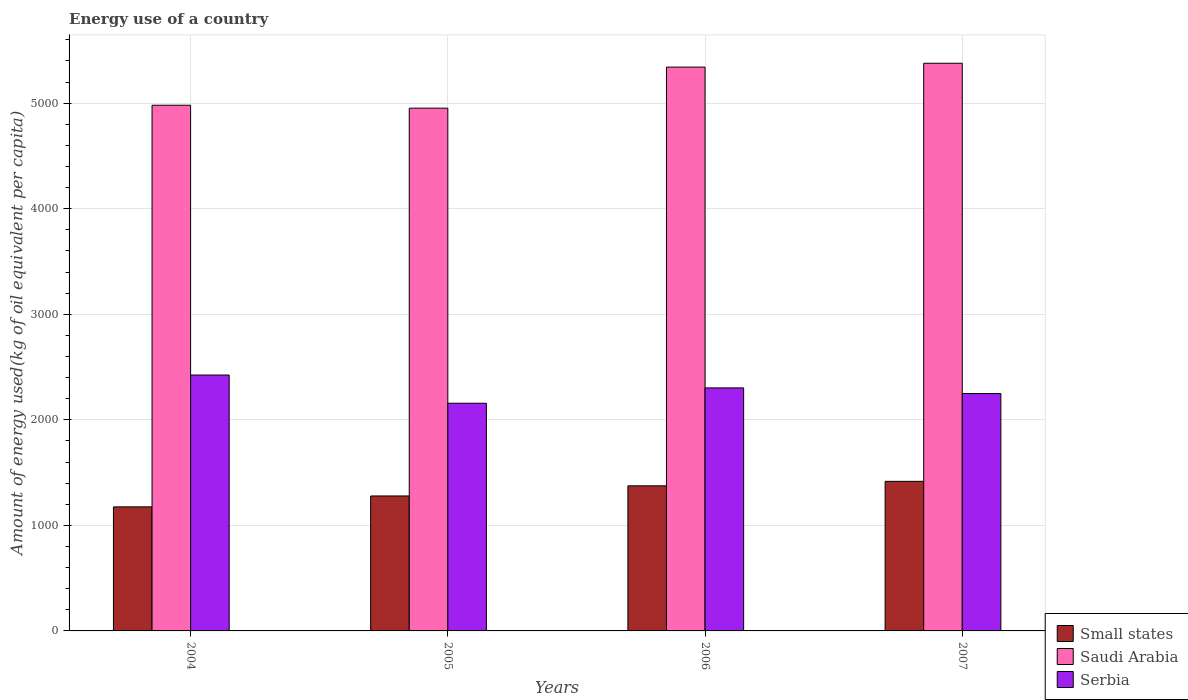How many different coloured bars are there?
Ensure brevity in your answer.  3. Are the number of bars per tick equal to the number of legend labels?
Keep it short and to the point. Yes. Are the number of bars on each tick of the X-axis equal?
Ensure brevity in your answer.  Yes. What is the label of the 4th group of bars from the left?
Keep it short and to the point. 2007. In how many cases, is the number of bars for a given year not equal to the number of legend labels?
Your answer should be very brief. 0. What is the amount of energy used in in Small states in 2007?
Ensure brevity in your answer.  1417.19. Across all years, what is the maximum amount of energy used in in Small states?
Your response must be concise. 1417.19. Across all years, what is the minimum amount of energy used in in Serbia?
Offer a very short reply. 2157.16. In which year was the amount of energy used in in Serbia maximum?
Give a very brief answer. 2004. What is the total amount of energy used in in Small states in the graph?
Your response must be concise. 5245.68. What is the difference between the amount of energy used in in Serbia in 2005 and that in 2006?
Your answer should be compact. -145.23. What is the difference between the amount of energy used in in Small states in 2007 and the amount of energy used in in Serbia in 2005?
Your answer should be very brief. -739.97. What is the average amount of energy used in in Saudi Arabia per year?
Provide a short and direct response. 5163.19. In the year 2006, what is the difference between the amount of energy used in in Saudi Arabia and amount of energy used in in Serbia?
Provide a succinct answer. 3039.44. In how many years, is the amount of energy used in in Saudi Arabia greater than 200 kg?
Your answer should be compact. 4. What is the ratio of the amount of energy used in in Serbia in 2004 to that in 2006?
Keep it short and to the point. 1.05. Is the difference between the amount of energy used in in Saudi Arabia in 2004 and 2005 greater than the difference between the amount of energy used in in Serbia in 2004 and 2005?
Your answer should be compact. No. What is the difference between the highest and the second highest amount of energy used in in Small states?
Offer a terse response. 42.63. What is the difference between the highest and the lowest amount of energy used in in Small states?
Your answer should be compact. 241.94. In how many years, is the amount of energy used in in Serbia greater than the average amount of energy used in in Serbia taken over all years?
Offer a very short reply. 2. What does the 2nd bar from the left in 2005 represents?
Provide a succinct answer. Saudi Arabia. What does the 1st bar from the right in 2007 represents?
Make the answer very short. Serbia. How many bars are there?
Your answer should be very brief. 12. Are all the bars in the graph horizontal?
Keep it short and to the point. No. Does the graph contain grids?
Offer a terse response. Yes. How many legend labels are there?
Provide a succinct answer. 3. What is the title of the graph?
Provide a short and direct response. Energy use of a country. Does "Low & middle income" appear as one of the legend labels in the graph?
Provide a succinct answer. No. What is the label or title of the X-axis?
Your answer should be very brief. Years. What is the label or title of the Y-axis?
Your answer should be very brief. Amount of energy used(kg of oil equivalent per capita). What is the Amount of energy used(kg of oil equivalent per capita) of Small states in 2004?
Offer a terse response. 1175.26. What is the Amount of energy used(kg of oil equivalent per capita) in Saudi Arabia in 2004?
Make the answer very short. 4980.31. What is the Amount of energy used(kg of oil equivalent per capita) in Serbia in 2004?
Provide a short and direct response. 2424.4. What is the Amount of energy used(kg of oil equivalent per capita) in Small states in 2005?
Make the answer very short. 1278.65. What is the Amount of energy used(kg of oil equivalent per capita) of Saudi Arabia in 2005?
Provide a succinct answer. 4952.56. What is the Amount of energy used(kg of oil equivalent per capita) in Serbia in 2005?
Your answer should be compact. 2157.16. What is the Amount of energy used(kg of oil equivalent per capita) of Small states in 2006?
Your answer should be very brief. 1374.57. What is the Amount of energy used(kg of oil equivalent per capita) of Saudi Arabia in 2006?
Keep it short and to the point. 5341.83. What is the Amount of energy used(kg of oil equivalent per capita) in Serbia in 2006?
Offer a very short reply. 2302.39. What is the Amount of energy used(kg of oil equivalent per capita) in Small states in 2007?
Ensure brevity in your answer.  1417.19. What is the Amount of energy used(kg of oil equivalent per capita) in Saudi Arabia in 2007?
Your response must be concise. 5378.06. What is the Amount of energy used(kg of oil equivalent per capita) in Serbia in 2007?
Offer a very short reply. 2249.08. Across all years, what is the maximum Amount of energy used(kg of oil equivalent per capita) in Small states?
Offer a terse response. 1417.19. Across all years, what is the maximum Amount of energy used(kg of oil equivalent per capita) of Saudi Arabia?
Your answer should be very brief. 5378.06. Across all years, what is the maximum Amount of energy used(kg of oil equivalent per capita) of Serbia?
Your answer should be compact. 2424.4. Across all years, what is the minimum Amount of energy used(kg of oil equivalent per capita) in Small states?
Provide a short and direct response. 1175.26. Across all years, what is the minimum Amount of energy used(kg of oil equivalent per capita) in Saudi Arabia?
Offer a very short reply. 4952.56. Across all years, what is the minimum Amount of energy used(kg of oil equivalent per capita) of Serbia?
Offer a very short reply. 2157.16. What is the total Amount of energy used(kg of oil equivalent per capita) in Small states in the graph?
Provide a short and direct response. 5245.68. What is the total Amount of energy used(kg of oil equivalent per capita) in Saudi Arabia in the graph?
Offer a very short reply. 2.07e+04. What is the total Amount of energy used(kg of oil equivalent per capita) in Serbia in the graph?
Ensure brevity in your answer.  9133.04. What is the difference between the Amount of energy used(kg of oil equivalent per capita) of Small states in 2004 and that in 2005?
Give a very brief answer. -103.39. What is the difference between the Amount of energy used(kg of oil equivalent per capita) of Saudi Arabia in 2004 and that in 2005?
Offer a very short reply. 27.75. What is the difference between the Amount of energy used(kg of oil equivalent per capita) in Serbia in 2004 and that in 2005?
Your answer should be compact. 267.24. What is the difference between the Amount of energy used(kg of oil equivalent per capita) of Small states in 2004 and that in 2006?
Give a very brief answer. -199.31. What is the difference between the Amount of energy used(kg of oil equivalent per capita) in Saudi Arabia in 2004 and that in 2006?
Your answer should be very brief. -361.52. What is the difference between the Amount of energy used(kg of oil equivalent per capita) in Serbia in 2004 and that in 2006?
Your response must be concise. 122.01. What is the difference between the Amount of energy used(kg of oil equivalent per capita) of Small states in 2004 and that in 2007?
Give a very brief answer. -241.94. What is the difference between the Amount of energy used(kg of oil equivalent per capita) of Saudi Arabia in 2004 and that in 2007?
Provide a succinct answer. -397.74. What is the difference between the Amount of energy used(kg of oil equivalent per capita) of Serbia in 2004 and that in 2007?
Offer a very short reply. 175.33. What is the difference between the Amount of energy used(kg of oil equivalent per capita) of Small states in 2005 and that in 2006?
Offer a terse response. -95.91. What is the difference between the Amount of energy used(kg of oil equivalent per capita) of Saudi Arabia in 2005 and that in 2006?
Your answer should be very brief. -389.27. What is the difference between the Amount of energy used(kg of oil equivalent per capita) in Serbia in 2005 and that in 2006?
Your answer should be compact. -145.23. What is the difference between the Amount of energy used(kg of oil equivalent per capita) in Small states in 2005 and that in 2007?
Give a very brief answer. -138.54. What is the difference between the Amount of energy used(kg of oil equivalent per capita) of Saudi Arabia in 2005 and that in 2007?
Make the answer very short. -425.5. What is the difference between the Amount of energy used(kg of oil equivalent per capita) of Serbia in 2005 and that in 2007?
Offer a terse response. -91.92. What is the difference between the Amount of energy used(kg of oil equivalent per capita) in Small states in 2006 and that in 2007?
Provide a short and direct response. -42.63. What is the difference between the Amount of energy used(kg of oil equivalent per capita) of Saudi Arabia in 2006 and that in 2007?
Make the answer very short. -36.23. What is the difference between the Amount of energy used(kg of oil equivalent per capita) of Serbia in 2006 and that in 2007?
Provide a succinct answer. 53.31. What is the difference between the Amount of energy used(kg of oil equivalent per capita) in Small states in 2004 and the Amount of energy used(kg of oil equivalent per capita) in Saudi Arabia in 2005?
Your answer should be compact. -3777.3. What is the difference between the Amount of energy used(kg of oil equivalent per capita) of Small states in 2004 and the Amount of energy used(kg of oil equivalent per capita) of Serbia in 2005?
Ensure brevity in your answer.  -981.9. What is the difference between the Amount of energy used(kg of oil equivalent per capita) of Saudi Arabia in 2004 and the Amount of energy used(kg of oil equivalent per capita) of Serbia in 2005?
Ensure brevity in your answer.  2823.15. What is the difference between the Amount of energy used(kg of oil equivalent per capita) of Small states in 2004 and the Amount of energy used(kg of oil equivalent per capita) of Saudi Arabia in 2006?
Make the answer very short. -4166.57. What is the difference between the Amount of energy used(kg of oil equivalent per capita) in Small states in 2004 and the Amount of energy used(kg of oil equivalent per capita) in Serbia in 2006?
Your answer should be compact. -1127.13. What is the difference between the Amount of energy used(kg of oil equivalent per capita) of Saudi Arabia in 2004 and the Amount of energy used(kg of oil equivalent per capita) of Serbia in 2006?
Offer a terse response. 2677.92. What is the difference between the Amount of energy used(kg of oil equivalent per capita) of Small states in 2004 and the Amount of energy used(kg of oil equivalent per capita) of Saudi Arabia in 2007?
Provide a succinct answer. -4202.8. What is the difference between the Amount of energy used(kg of oil equivalent per capita) of Small states in 2004 and the Amount of energy used(kg of oil equivalent per capita) of Serbia in 2007?
Your answer should be compact. -1073.82. What is the difference between the Amount of energy used(kg of oil equivalent per capita) in Saudi Arabia in 2004 and the Amount of energy used(kg of oil equivalent per capita) in Serbia in 2007?
Ensure brevity in your answer.  2731.23. What is the difference between the Amount of energy used(kg of oil equivalent per capita) in Small states in 2005 and the Amount of energy used(kg of oil equivalent per capita) in Saudi Arabia in 2006?
Ensure brevity in your answer.  -4063.18. What is the difference between the Amount of energy used(kg of oil equivalent per capita) in Small states in 2005 and the Amount of energy used(kg of oil equivalent per capita) in Serbia in 2006?
Provide a succinct answer. -1023.74. What is the difference between the Amount of energy used(kg of oil equivalent per capita) in Saudi Arabia in 2005 and the Amount of energy used(kg of oil equivalent per capita) in Serbia in 2006?
Your response must be concise. 2650.17. What is the difference between the Amount of energy used(kg of oil equivalent per capita) in Small states in 2005 and the Amount of energy used(kg of oil equivalent per capita) in Saudi Arabia in 2007?
Keep it short and to the point. -4099.4. What is the difference between the Amount of energy used(kg of oil equivalent per capita) of Small states in 2005 and the Amount of energy used(kg of oil equivalent per capita) of Serbia in 2007?
Your answer should be very brief. -970.42. What is the difference between the Amount of energy used(kg of oil equivalent per capita) in Saudi Arabia in 2005 and the Amount of energy used(kg of oil equivalent per capita) in Serbia in 2007?
Offer a terse response. 2703.48. What is the difference between the Amount of energy used(kg of oil equivalent per capita) in Small states in 2006 and the Amount of energy used(kg of oil equivalent per capita) in Saudi Arabia in 2007?
Offer a terse response. -4003.49. What is the difference between the Amount of energy used(kg of oil equivalent per capita) of Small states in 2006 and the Amount of energy used(kg of oil equivalent per capita) of Serbia in 2007?
Ensure brevity in your answer.  -874.51. What is the difference between the Amount of energy used(kg of oil equivalent per capita) in Saudi Arabia in 2006 and the Amount of energy used(kg of oil equivalent per capita) in Serbia in 2007?
Give a very brief answer. 3092.75. What is the average Amount of energy used(kg of oil equivalent per capita) in Small states per year?
Offer a terse response. 1311.42. What is the average Amount of energy used(kg of oil equivalent per capita) of Saudi Arabia per year?
Offer a very short reply. 5163.19. What is the average Amount of energy used(kg of oil equivalent per capita) of Serbia per year?
Provide a succinct answer. 2283.26. In the year 2004, what is the difference between the Amount of energy used(kg of oil equivalent per capita) of Small states and Amount of energy used(kg of oil equivalent per capita) of Saudi Arabia?
Your answer should be compact. -3805.05. In the year 2004, what is the difference between the Amount of energy used(kg of oil equivalent per capita) of Small states and Amount of energy used(kg of oil equivalent per capita) of Serbia?
Provide a short and direct response. -1249.15. In the year 2004, what is the difference between the Amount of energy used(kg of oil equivalent per capita) of Saudi Arabia and Amount of energy used(kg of oil equivalent per capita) of Serbia?
Provide a succinct answer. 2555.91. In the year 2005, what is the difference between the Amount of energy used(kg of oil equivalent per capita) in Small states and Amount of energy used(kg of oil equivalent per capita) in Saudi Arabia?
Make the answer very short. -3673.91. In the year 2005, what is the difference between the Amount of energy used(kg of oil equivalent per capita) in Small states and Amount of energy used(kg of oil equivalent per capita) in Serbia?
Ensure brevity in your answer.  -878.51. In the year 2005, what is the difference between the Amount of energy used(kg of oil equivalent per capita) of Saudi Arabia and Amount of energy used(kg of oil equivalent per capita) of Serbia?
Keep it short and to the point. 2795.4. In the year 2006, what is the difference between the Amount of energy used(kg of oil equivalent per capita) in Small states and Amount of energy used(kg of oil equivalent per capita) in Saudi Arabia?
Keep it short and to the point. -3967.26. In the year 2006, what is the difference between the Amount of energy used(kg of oil equivalent per capita) in Small states and Amount of energy used(kg of oil equivalent per capita) in Serbia?
Offer a very short reply. -927.82. In the year 2006, what is the difference between the Amount of energy used(kg of oil equivalent per capita) in Saudi Arabia and Amount of energy used(kg of oil equivalent per capita) in Serbia?
Offer a terse response. 3039.44. In the year 2007, what is the difference between the Amount of energy used(kg of oil equivalent per capita) in Small states and Amount of energy used(kg of oil equivalent per capita) in Saudi Arabia?
Your answer should be very brief. -3960.86. In the year 2007, what is the difference between the Amount of energy used(kg of oil equivalent per capita) of Small states and Amount of energy used(kg of oil equivalent per capita) of Serbia?
Your response must be concise. -831.88. In the year 2007, what is the difference between the Amount of energy used(kg of oil equivalent per capita) of Saudi Arabia and Amount of energy used(kg of oil equivalent per capita) of Serbia?
Give a very brief answer. 3128.98. What is the ratio of the Amount of energy used(kg of oil equivalent per capita) in Small states in 2004 to that in 2005?
Keep it short and to the point. 0.92. What is the ratio of the Amount of energy used(kg of oil equivalent per capita) of Saudi Arabia in 2004 to that in 2005?
Your response must be concise. 1.01. What is the ratio of the Amount of energy used(kg of oil equivalent per capita) of Serbia in 2004 to that in 2005?
Make the answer very short. 1.12. What is the ratio of the Amount of energy used(kg of oil equivalent per capita) in Small states in 2004 to that in 2006?
Provide a short and direct response. 0.85. What is the ratio of the Amount of energy used(kg of oil equivalent per capita) of Saudi Arabia in 2004 to that in 2006?
Keep it short and to the point. 0.93. What is the ratio of the Amount of energy used(kg of oil equivalent per capita) of Serbia in 2004 to that in 2006?
Provide a succinct answer. 1.05. What is the ratio of the Amount of energy used(kg of oil equivalent per capita) in Small states in 2004 to that in 2007?
Your response must be concise. 0.83. What is the ratio of the Amount of energy used(kg of oil equivalent per capita) in Saudi Arabia in 2004 to that in 2007?
Ensure brevity in your answer.  0.93. What is the ratio of the Amount of energy used(kg of oil equivalent per capita) of Serbia in 2004 to that in 2007?
Offer a very short reply. 1.08. What is the ratio of the Amount of energy used(kg of oil equivalent per capita) of Small states in 2005 to that in 2006?
Give a very brief answer. 0.93. What is the ratio of the Amount of energy used(kg of oil equivalent per capita) of Saudi Arabia in 2005 to that in 2006?
Offer a terse response. 0.93. What is the ratio of the Amount of energy used(kg of oil equivalent per capita) in Serbia in 2005 to that in 2006?
Offer a very short reply. 0.94. What is the ratio of the Amount of energy used(kg of oil equivalent per capita) in Small states in 2005 to that in 2007?
Give a very brief answer. 0.9. What is the ratio of the Amount of energy used(kg of oil equivalent per capita) of Saudi Arabia in 2005 to that in 2007?
Offer a terse response. 0.92. What is the ratio of the Amount of energy used(kg of oil equivalent per capita) of Serbia in 2005 to that in 2007?
Offer a terse response. 0.96. What is the ratio of the Amount of energy used(kg of oil equivalent per capita) of Small states in 2006 to that in 2007?
Provide a succinct answer. 0.97. What is the ratio of the Amount of energy used(kg of oil equivalent per capita) of Saudi Arabia in 2006 to that in 2007?
Your answer should be compact. 0.99. What is the ratio of the Amount of energy used(kg of oil equivalent per capita) of Serbia in 2006 to that in 2007?
Keep it short and to the point. 1.02. What is the difference between the highest and the second highest Amount of energy used(kg of oil equivalent per capita) of Small states?
Make the answer very short. 42.63. What is the difference between the highest and the second highest Amount of energy used(kg of oil equivalent per capita) in Saudi Arabia?
Give a very brief answer. 36.23. What is the difference between the highest and the second highest Amount of energy used(kg of oil equivalent per capita) in Serbia?
Your answer should be compact. 122.01. What is the difference between the highest and the lowest Amount of energy used(kg of oil equivalent per capita) in Small states?
Keep it short and to the point. 241.94. What is the difference between the highest and the lowest Amount of energy used(kg of oil equivalent per capita) of Saudi Arabia?
Offer a terse response. 425.5. What is the difference between the highest and the lowest Amount of energy used(kg of oil equivalent per capita) of Serbia?
Your answer should be very brief. 267.24. 